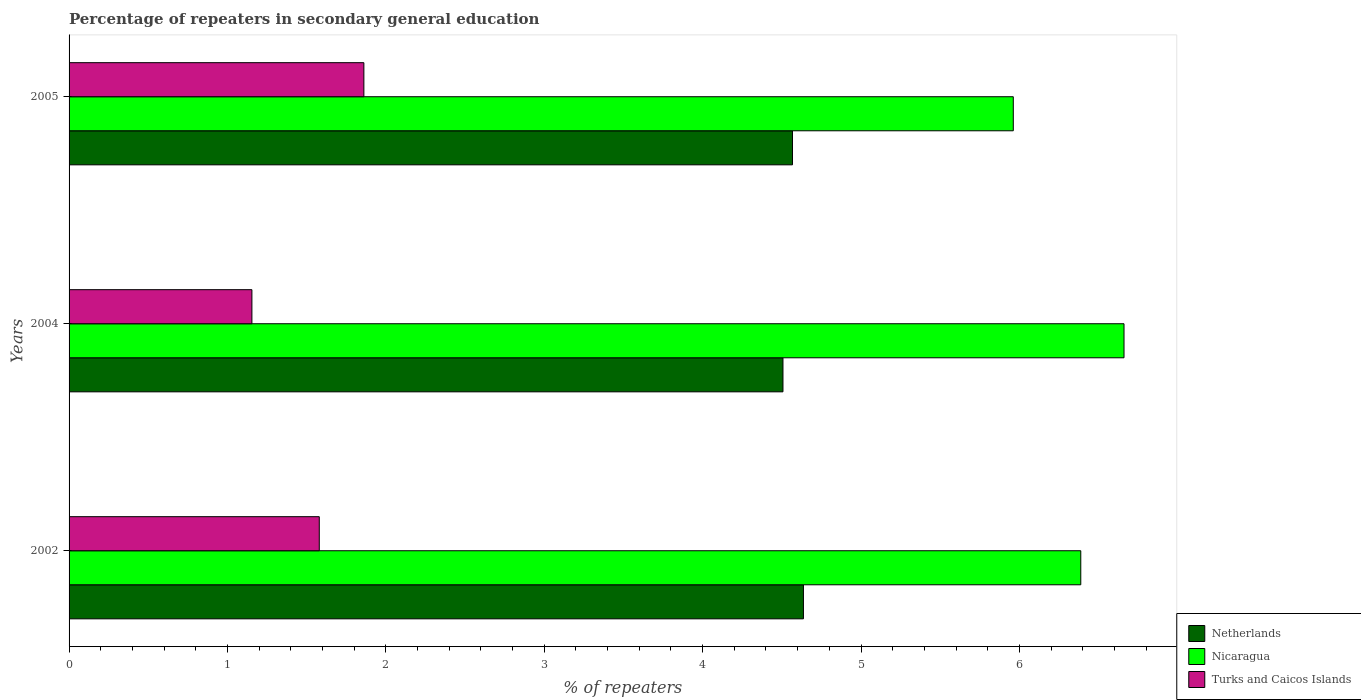How many different coloured bars are there?
Provide a succinct answer. 3. Are the number of bars per tick equal to the number of legend labels?
Offer a terse response. Yes. In how many cases, is the number of bars for a given year not equal to the number of legend labels?
Provide a succinct answer. 0. What is the percentage of repeaters in secondary general education in Nicaragua in 2004?
Offer a terse response. 6.66. Across all years, what is the maximum percentage of repeaters in secondary general education in Turks and Caicos Islands?
Offer a terse response. 1.86. Across all years, what is the minimum percentage of repeaters in secondary general education in Netherlands?
Offer a very short reply. 4.51. In which year was the percentage of repeaters in secondary general education in Turks and Caicos Islands minimum?
Give a very brief answer. 2004. What is the total percentage of repeaters in secondary general education in Turks and Caicos Islands in the graph?
Your response must be concise. 4.6. What is the difference between the percentage of repeaters in secondary general education in Turks and Caicos Islands in 2004 and that in 2005?
Offer a very short reply. -0.71. What is the difference between the percentage of repeaters in secondary general education in Turks and Caicos Islands in 2005 and the percentage of repeaters in secondary general education in Nicaragua in 2002?
Offer a terse response. -4.53. What is the average percentage of repeaters in secondary general education in Turks and Caicos Islands per year?
Offer a very short reply. 1.53. In the year 2002, what is the difference between the percentage of repeaters in secondary general education in Nicaragua and percentage of repeaters in secondary general education in Turks and Caicos Islands?
Provide a succinct answer. 4.81. What is the ratio of the percentage of repeaters in secondary general education in Nicaragua in 2002 to that in 2005?
Make the answer very short. 1.07. Is the difference between the percentage of repeaters in secondary general education in Nicaragua in 2002 and 2005 greater than the difference between the percentage of repeaters in secondary general education in Turks and Caicos Islands in 2002 and 2005?
Offer a terse response. Yes. What is the difference between the highest and the second highest percentage of repeaters in secondary general education in Turks and Caicos Islands?
Offer a terse response. 0.28. What is the difference between the highest and the lowest percentage of repeaters in secondary general education in Netherlands?
Make the answer very short. 0.13. What does the 2nd bar from the top in 2005 represents?
Give a very brief answer. Nicaragua. What does the 2nd bar from the bottom in 2002 represents?
Offer a terse response. Nicaragua. Are all the bars in the graph horizontal?
Keep it short and to the point. Yes. How many years are there in the graph?
Your answer should be compact. 3. What is the difference between two consecutive major ticks on the X-axis?
Your answer should be compact. 1. Are the values on the major ticks of X-axis written in scientific E-notation?
Offer a terse response. No. Does the graph contain grids?
Your answer should be very brief. No. Where does the legend appear in the graph?
Offer a very short reply. Bottom right. How many legend labels are there?
Offer a terse response. 3. How are the legend labels stacked?
Offer a terse response. Vertical. What is the title of the graph?
Provide a short and direct response. Percentage of repeaters in secondary general education. Does "Djibouti" appear as one of the legend labels in the graph?
Offer a very short reply. No. What is the label or title of the X-axis?
Provide a short and direct response. % of repeaters. What is the % of repeaters of Netherlands in 2002?
Your answer should be very brief. 4.64. What is the % of repeaters in Nicaragua in 2002?
Offer a terse response. 6.39. What is the % of repeaters of Turks and Caicos Islands in 2002?
Make the answer very short. 1.58. What is the % of repeaters in Netherlands in 2004?
Make the answer very short. 4.51. What is the % of repeaters in Nicaragua in 2004?
Offer a terse response. 6.66. What is the % of repeaters of Turks and Caicos Islands in 2004?
Give a very brief answer. 1.15. What is the % of repeaters in Netherlands in 2005?
Offer a terse response. 4.57. What is the % of repeaters in Nicaragua in 2005?
Your response must be concise. 5.96. What is the % of repeaters in Turks and Caicos Islands in 2005?
Provide a short and direct response. 1.86. Across all years, what is the maximum % of repeaters of Netherlands?
Keep it short and to the point. 4.64. Across all years, what is the maximum % of repeaters of Nicaragua?
Make the answer very short. 6.66. Across all years, what is the maximum % of repeaters of Turks and Caicos Islands?
Your answer should be compact. 1.86. Across all years, what is the minimum % of repeaters in Netherlands?
Ensure brevity in your answer.  4.51. Across all years, what is the minimum % of repeaters in Nicaragua?
Offer a terse response. 5.96. Across all years, what is the minimum % of repeaters in Turks and Caicos Islands?
Your response must be concise. 1.15. What is the total % of repeaters in Netherlands in the graph?
Your response must be concise. 13.71. What is the total % of repeaters in Nicaragua in the graph?
Offer a very short reply. 19.01. What is the total % of repeaters in Turks and Caicos Islands in the graph?
Your answer should be compact. 4.6. What is the difference between the % of repeaters of Netherlands in 2002 and that in 2004?
Keep it short and to the point. 0.13. What is the difference between the % of repeaters of Nicaragua in 2002 and that in 2004?
Keep it short and to the point. -0.27. What is the difference between the % of repeaters of Turks and Caicos Islands in 2002 and that in 2004?
Ensure brevity in your answer.  0.43. What is the difference between the % of repeaters in Netherlands in 2002 and that in 2005?
Offer a terse response. 0.07. What is the difference between the % of repeaters of Nicaragua in 2002 and that in 2005?
Give a very brief answer. 0.43. What is the difference between the % of repeaters of Turks and Caicos Islands in 2002 and that in 2005?
Provide a short and direct response. -0.28. What is the difference between the % of repeaters of Netherlands in 2004 and that in 2005?
Provide a short and direct response. -0.06. What is the difference between the % of repeaters of Nicaragua in 2004 and that in 2005?
Offer a terse response. 0.7. What is the difference between the % of repeaters of Turks and Caicos Islands in 2004 and that in 2005?
Your response must be concise. -0.71. What is the difference between the % of repeaters of Netherlands in 2002 and the % of repeaters of Nicaragua in 2004?
Keep it short and to the point. -2.02. What is the difference between the % of repeaters of Netherlands in 2002 and the % of repeaters of Turks and Caicos Islands in 2004?
Give a very brief answer. 3.48. What is the difference between the % of repeaters in Nicaragua in 2002 and the % of repeaters in Turks and Caicos Islands in 2004?
Your answer should be very brief. 5.23. What is the difference between the % of repeaters of Netherlands in 2002 and the % of repeaters of Nicaragua in 2005?
Your answer should be compact. -1.32. What is the difference between the % of repeaters of Netherlands in 2002 and the % of repeaters of Turks and Caicos Islands in 2005?
Give a very brief answer. 2.78. What is the difference between the % of repeaters of Nicaragua in 2002 and the % of repeaters of Turks and Caicos Islands in 2005?
Ensure brevity in your answer.  4.53. What is the difference between the % of repeaters of Netherlands in 2004 and the % of repeaters of Nicaragua in 2005?
Offer a terse response. -1.45. What is the difference between the % of repeaters of Netherlands in 2004 and the % of repeaters of Turks and Caicos Islands in 2005?
Give a very brief answer. 2.65. What is the difference between the % of repeaters in Nicaragua in 2004 and the % of repeaters in Turks and Caicos Islands in 2005?
Your response must be concise. 4.8. What is the average % of repeaters in Netherlands per year?
Your response must be concise. 4.57. What is the average % of repeaters of Nicaragua per year?
Provide a succinct answer. 6.34. What is the average % of repeaters of Turks and Caicos Islands per year?
Provide a short and direct response. 1.53. In the year 2002, what is the difference between the % of repeaters of Netherlands and % of repeaters of Nicaragua?
Make the answer very short. -1.75. In the year 2002, what is the difference between the % of repeaters of Netherlands and % of repeaters of Turks and Caicos Islands?
Your answer should be compact. 3.06. In the year 2002, what is the difference between the % of repeaters in Nicaragua and % of repeaters in Turks and Caicos Islands?
Keep it short and to the point. 4.81. In the year 2004, what is the difference between the % of repeaters of Netherlands and % of repeaters of Nicaragua?
Your answer should be very brief. -2.15. In the year 2004, what is the difference between the % of repeaters of Netherlands and % of repeaters of Turks and Caicos Islands?
Your answer should be compact. 3.35. In the year 2004, what is the difference between the % of repeaters of Nicaragua and % of repeaters of Turks and Caicos Islands?
Provide a short and direct response. 5.51. In the year 2005, what is the difference between the % of repeaters of Netherlands and % of repeaters of Nicaragua?
Give a very brief answer. -1.39. In the year 2005, what is the difference between the % of repeaters in Netherlands and % of repeaters in Turks and Caicos Islands?
Your response must be concise. 2.71. In the year 2005, what is the difference between the % of repeaters in Nicaragua and % of repeaters in Turks and Caicos Islands?
Provide a short and direct response. 4.1. What is the ratio of the % of repeaters in Netherlands in 2002 to that in 2004?
Offer a terse response. 1.03. What is the ratio of the % of repeaters of Nicaragua in 2002 to that in 2004?
Ensure brevity in your answer.  0.96. What is the ratio of the % of repeaters of Turks and Caicos Islands in 2002 to that in 2004?
Offer a very short reply. 1.37. What is the ratio of the % of repeaters in Netherlands in 2002 to that in 2005?
Offer a terse response. 1.02. What is the ratio of the % of repeaters in Nicaragua in 2002 to that in 2005?
Keep it short and to the point. 1.07. What is the ratio of the % of repeaters in Turks and Caicos Islands in 2002 to that in 2005?
Your answer should be compact. 0.85. What is the ratio of the % of repeaters in Nicaragua in 2004 to that in 2005?
Ensure brevity in your answer.  1.12. What is the ratio of the % of repeaters in Turks and Caicos Islands in 2004 to that in 2005?
Ensure brevity in your answer.  0.62. What is the difference between the highest and the second highest % of repeaters of Netherlands?
Provide a succinct answer. 0.07. What is the difference between the highest and the second highest % of repeaters of Nicaragua?
Give a very brief answer. 0.27. What is the difference between the highest and the second highest % of repeaters in Turks and Caicos Islands?
Give a very brief answer. 0.28. What is the difference between the highest and the lowest % of repeaters of Netherlands?
Your answer should be very brief. 0.13. What is the difference between the highest and the lowest % of repeaters of Nicaragua?
Your response must be concise. 0.7. What is the difference between the highest and the lowest % of repeaters of Turks and Caicos Islands?
Offer a very short reply. 0.71. 